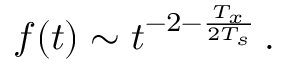<formula> <loc_0><loc_0><loc_500><loc_500>f ( t ) \sim t ^ { - 2 - \frac { T _ { x } } { 2 T _ { s } } } \, .</formula> 